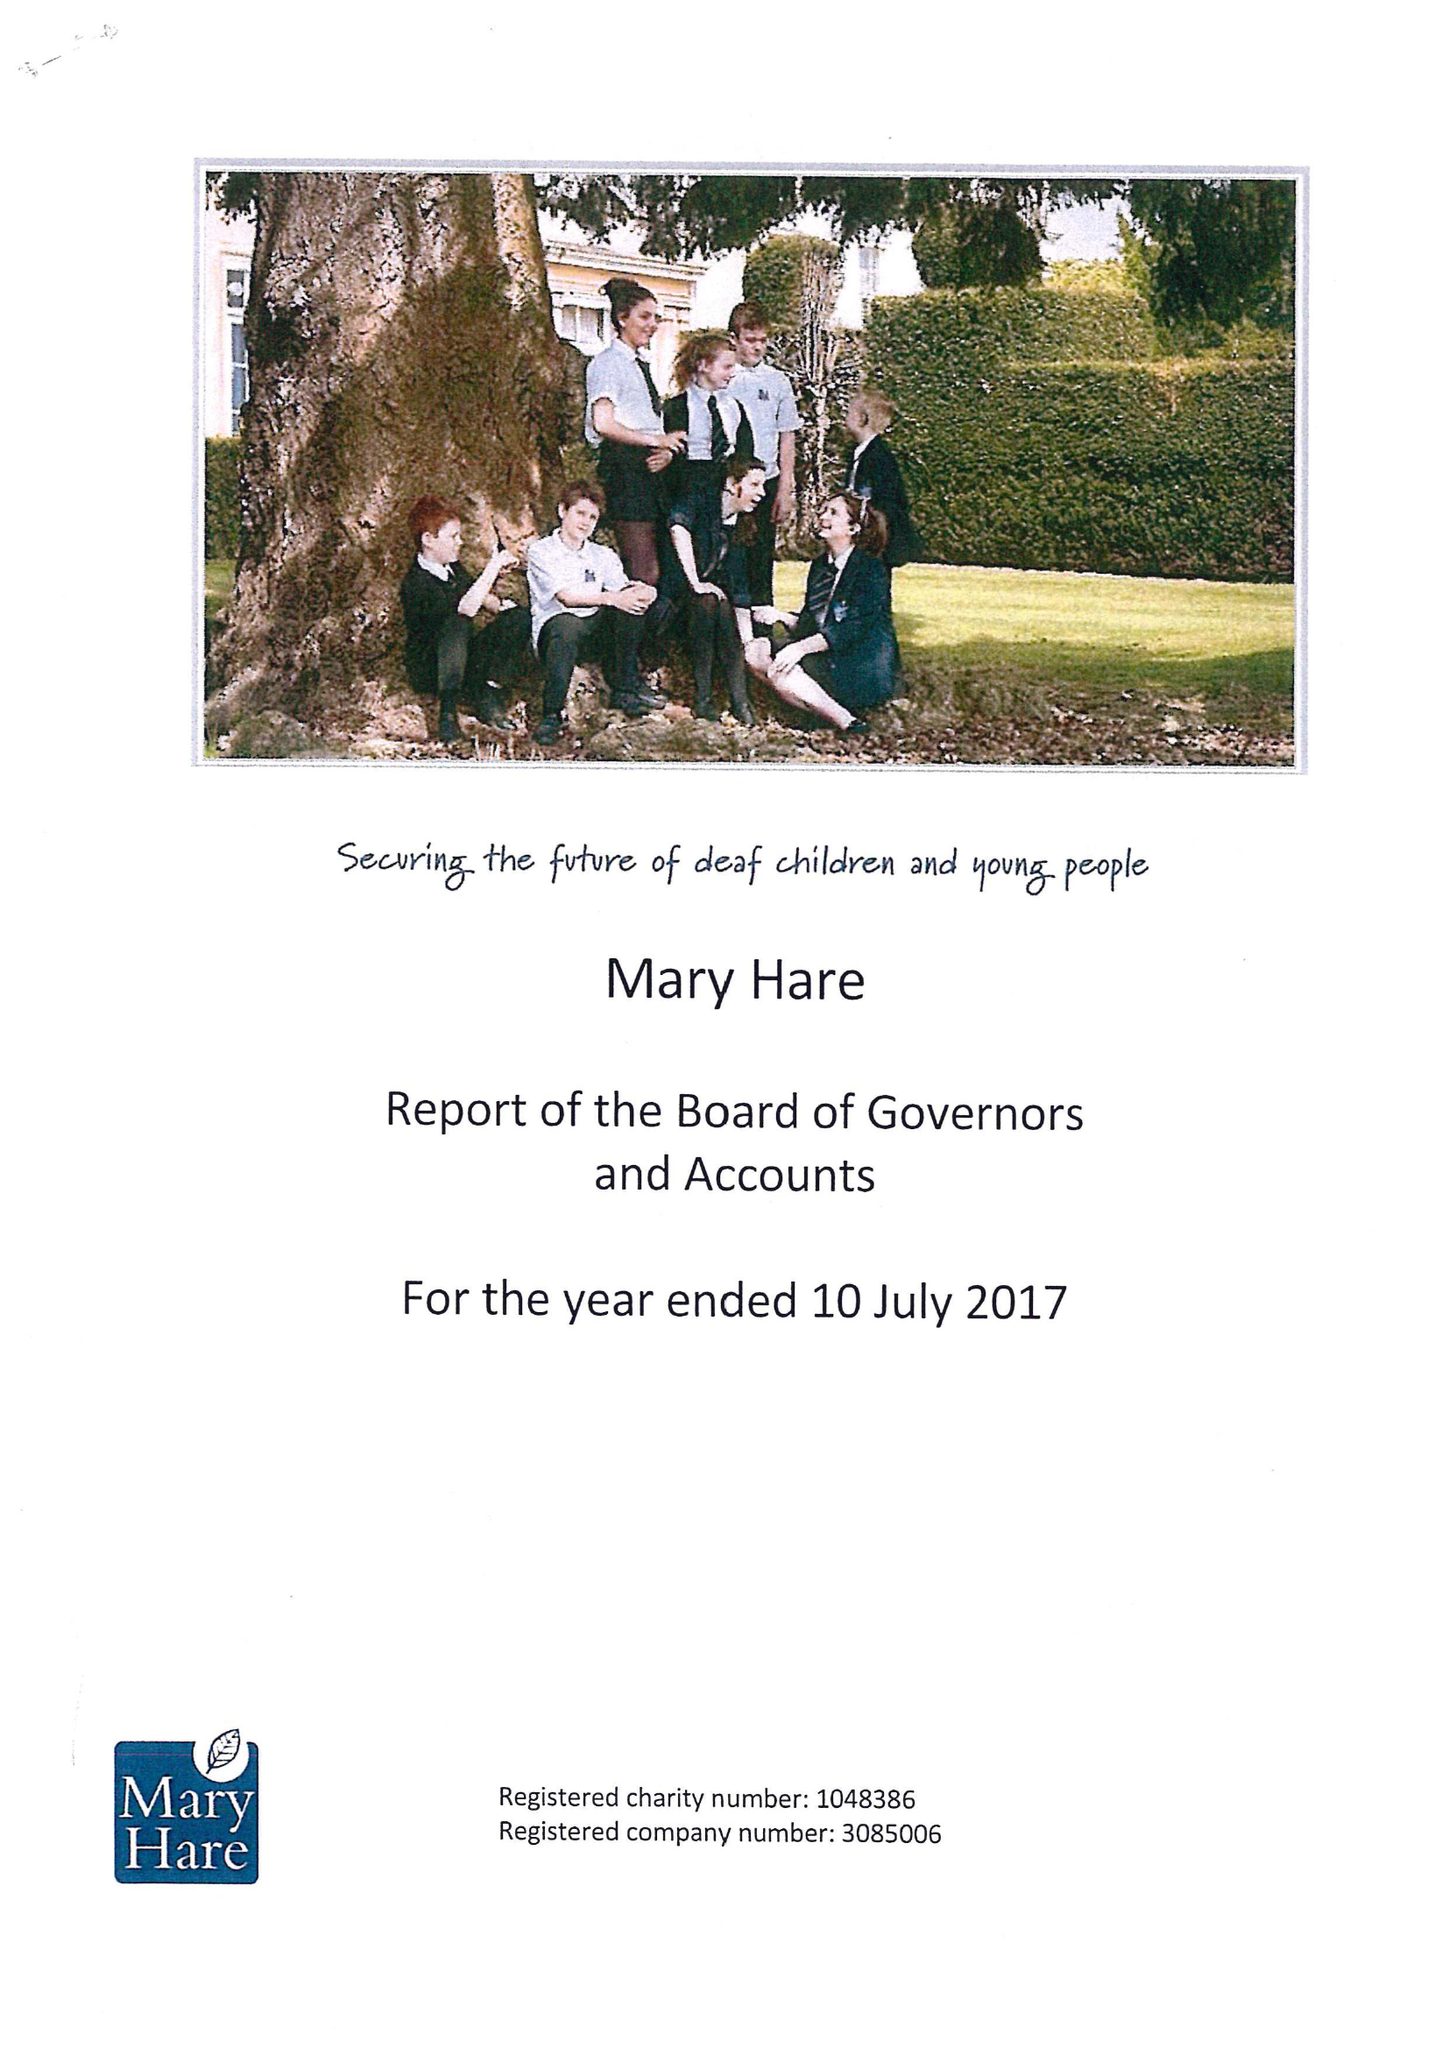What is the value for the charity_number?
Answer the question using a single word or phrase. 1048386 